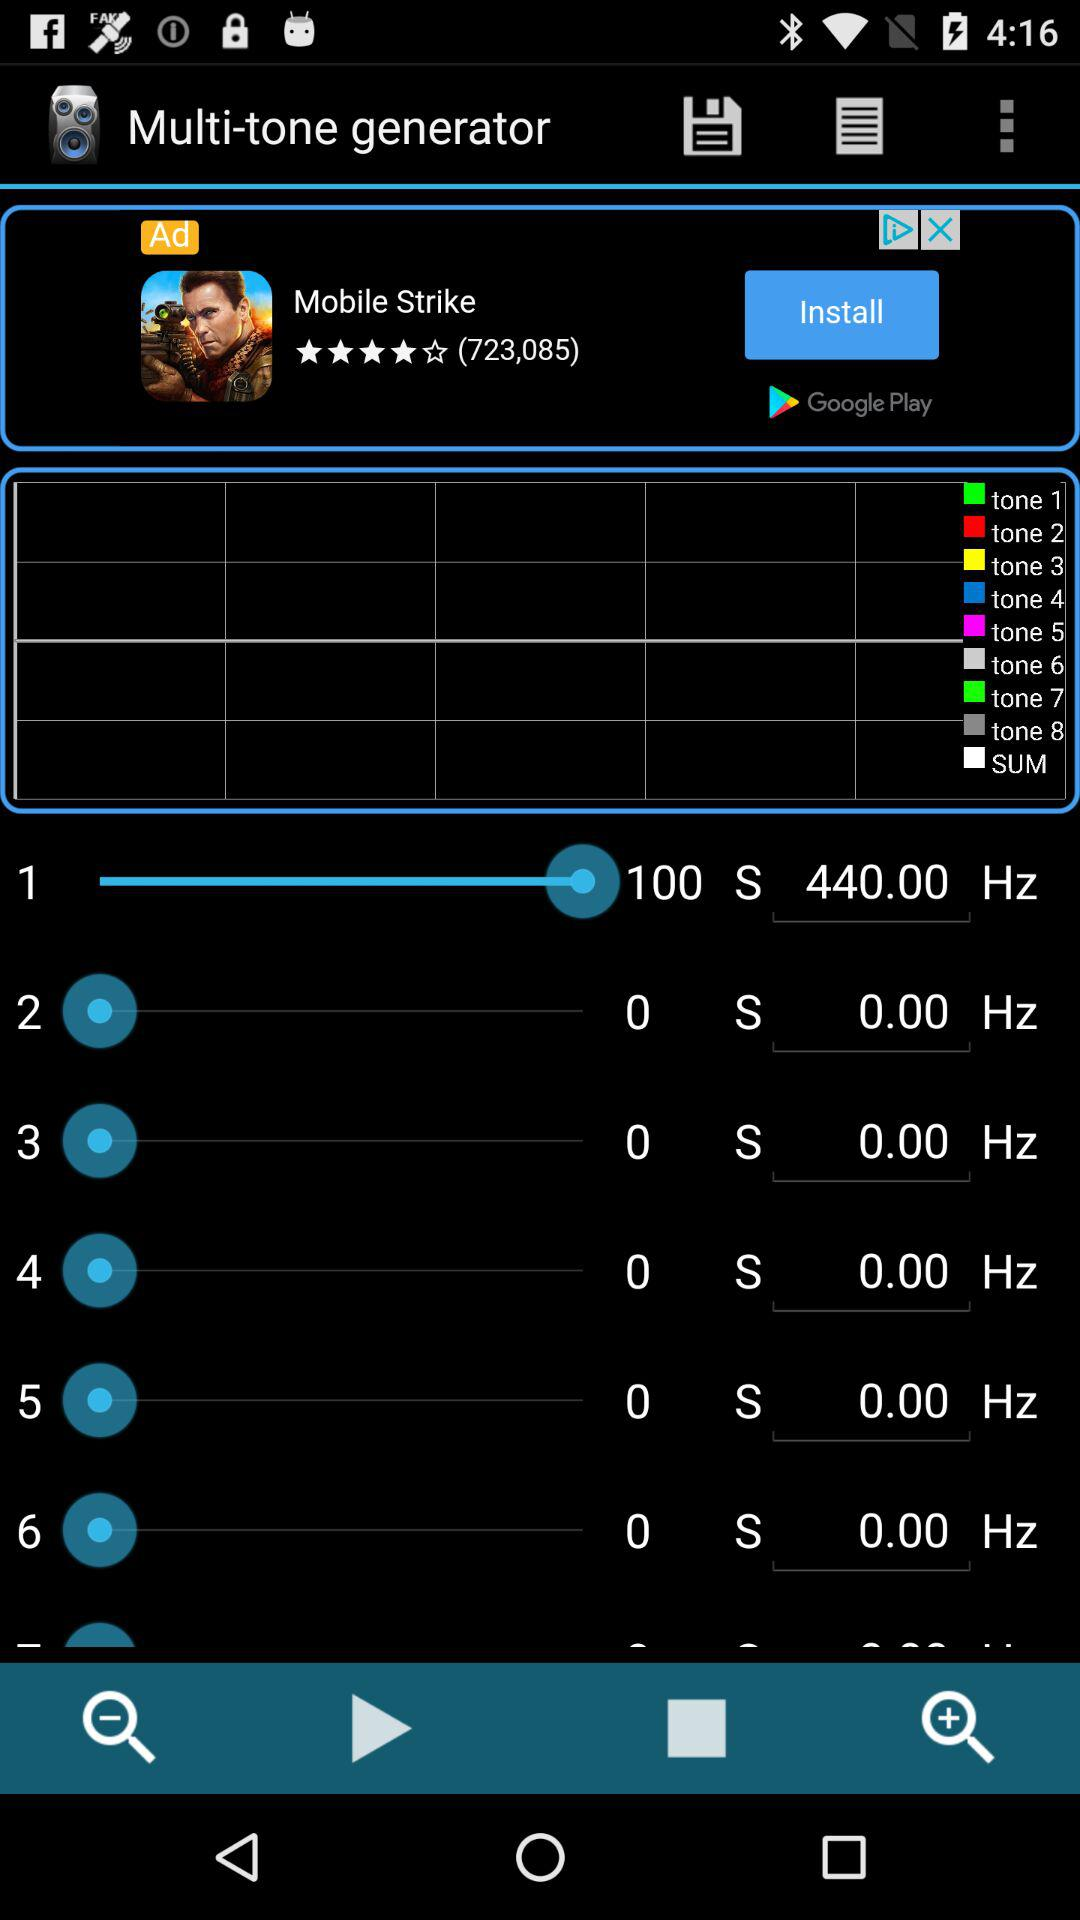What is the application name? The application name is "Multi-tone generator". 